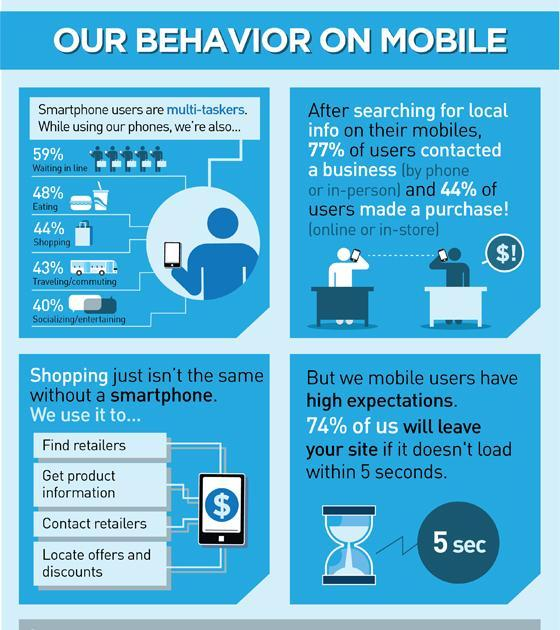How many of the users use smartphone while travelling?
Answer the question with a short phrase. 43% What is the minimum site loading time beyond which users leave the site? 5 sec What percent of people use smartphones while eating? 48% What do we use these days to find retailers, locate offers and discounts? A smartphone 